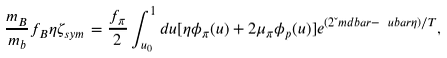Convert formula to latex. <formula><loc_0><loc_0><loc_500><loc_500>\frac { m _ { B } } { m _ { b } } f _ { B } \eta \zeta _ { s y m } = \frac { f _ { \pi } } { 2 } \int _ { u _ { 0 } } ^ { 1 } d u [ \eta \phi _ { \pi } ( u ) + 2 \mu _ { \pi } \phi _ { p } ( u ) ] e ^ { ( 2 \L m d b a r - \ u b a r \eta ) / T } ,</formula> 